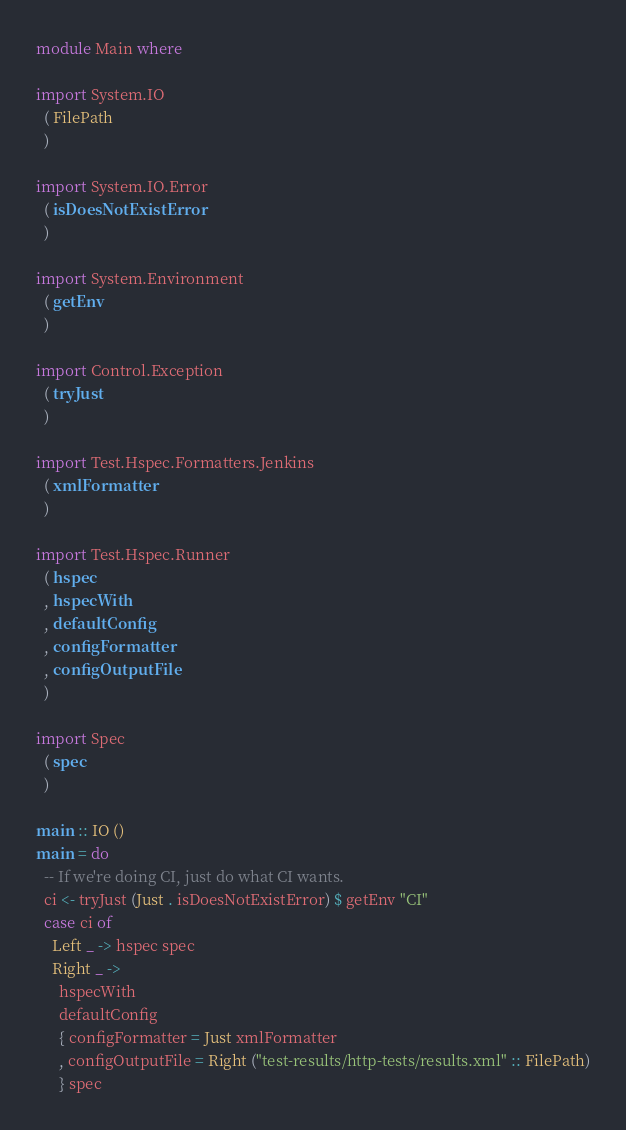<code> <loc_0><loc_0><loc_500><loc_500><_Haskell_>module Main where

import System.IO
  ( FilePath
  )

import System.IO.Error
  ( isDoesNotExistError
  )

import System.Environment
  ( getEnv
  )

import Control.Exception
  ( tryJust
  )

import Test.Hspec.Formatters.Jenkins
  ( xmlFormatter
  )

import Test.Hspec.Runner
  ( hspec
  , hspecWith
  , defaultConfig
  , configFormatter
  , configOutputFile
  )

import Spec
  ( spec
  )

main :: IO ()
main = do
  -- If we're doing CI, just do what CI wants.
  ci <- tryJust (Just . isDoesNotExistError) $ getEnv "CI"
  case ci of
    Left _ -> hspec spec
    Right _ ->
      hspecWith
      defaultConfig
      { configFormatter = Just xmlFormatter
      , configOutputFile = Right ("test-results/http-tests/results.xml" :: FilePath)
      } spec
</code> 